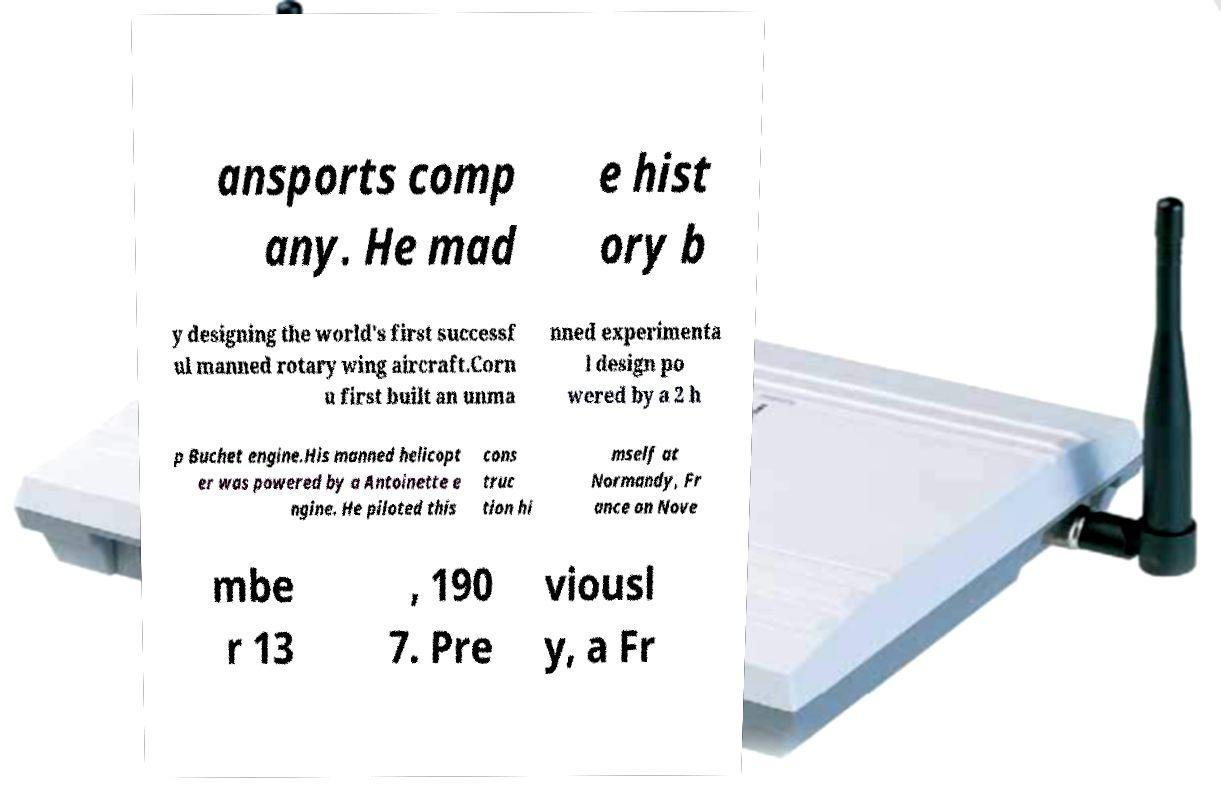Please identify and transcribe the text found in this image. ansports comp any. He mad e hist ory b y designing the world's first successf ul manned rotary wing aircraft.Corn u first built an unma nned experimenta l design po wered by a 2 h p Buchet engine.His manned helicopt er was powered by a Antoinette e ngine. He piloted this cons truc tion hi mself at Normandy, Fr ance on Nove mbe r 13 , 190 7. Pre viousl y, a Fr 